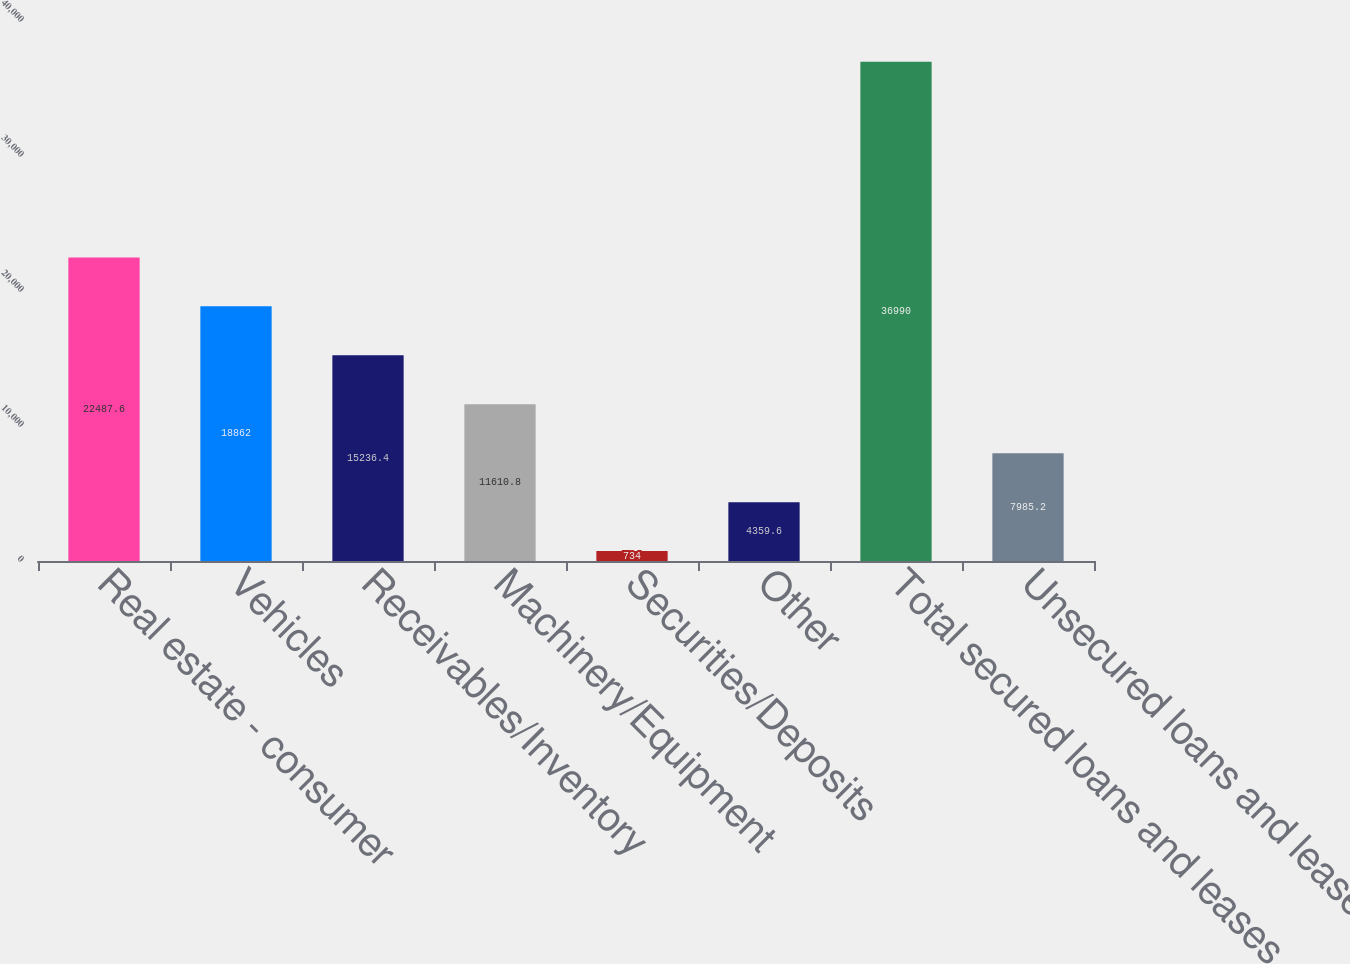<chart> <loc_0><loc_0><loc_500><loc_500><bar_chart><fcel>Real estate - consumer<fcel>Vehicles<fcel>Receivables/Inventory<fcel>Machinery/Equipment<fcel>Securities/Deposits<fcel>Other<fcel>Total secured loans and leases<fcel>Unsecured loans and leases<nl><fcel>22487.6<fcel>18862<fcel>15236.4<fcel>11610.8<fcel>734<fcel>4359.6<fcel>36990<fcel>7985.2<nl></chart> 